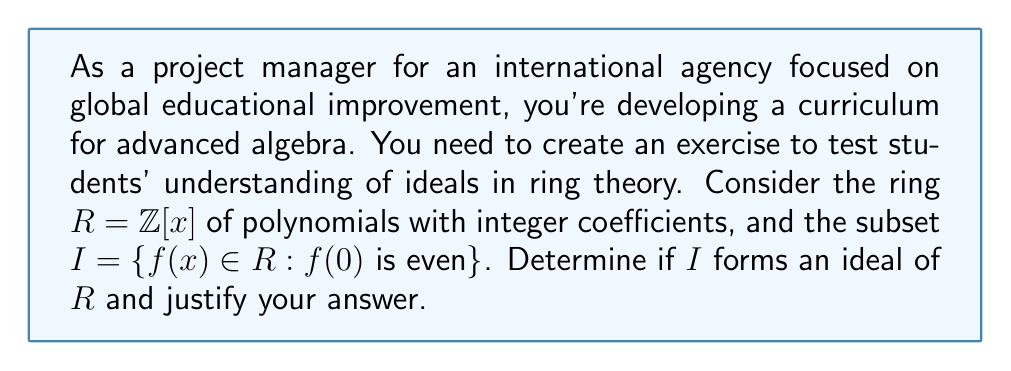Solve this math problem. To determine if $I$ forms an ideal of $R$, we need to check three conditions:

1. $I$ is a subgroup of $(R, +)$
2. For all $a \in I$ and $r \in R$, $ra \in I$
3. For all $a \in I$ and $r \in R$, $ar \in I$

Let's check each condition:

1. $I$ is a subgroup of $(R, +)$:
   - $0 \in I$ since $0(0) = 0$ is even.
   - If $f(x), g(x) \in I$, then $f(0)$ and $g(0)$ are even. $(f+g)(0) = f(0) + g(0)$ is also even, so $f(x) + g(x) \in I$.
   - If $f(x) \in I$, then $-f(x) \in I$ because $(-f)(0) = -f(0)$ is also even.

   Therefore, $I$ is a subgroup of $(R, +)$.

2. For all $a \in I$ and $r \in R$, $ra \in I$:
   Let $a(x) \in I$ and $r(x) \in R$. Then $a(0)$ is even.
   $(ra)(0) = r(0)a(0)$ is even because it's the product of an integer and an even number.
   So $ra \in I$.

3. For all $a \in I$ and $r \in R$, $ar \in I$:
   This condition fails. Consider $a(x) = 2 \in I$ and $r(x) = x \in R$.
   $(ar)(x) = 2x \in R$, but $(ar)(0) = 2 \cdot 0 = 0$, which is even.
   However, take $a(x) = 2 \in I$ and $r(x) = x+1 \in R$.
   $(ar)(x) = 2(x+1) = 2x + 2$, but $(ar)(0) = 2 \cdot 1 = 2$, which is even.
   So $ar \in I$ in this case.

Since condition 3 is not always satisfied, $I$ is not an ideal of $R$.
Answer: $I$ is not an ideal of $R = \mathbb{Z}[x]$ because it doesn't satisfy the condition that for all $a \in I$ and $r \in R$, $ar \in I$. 